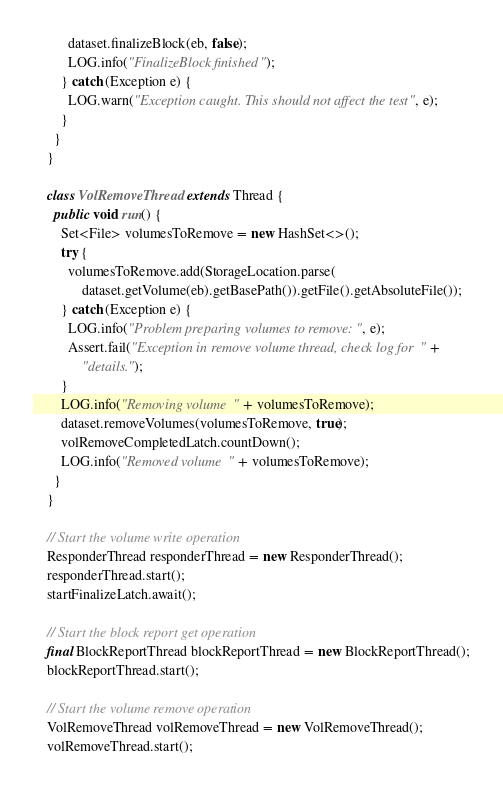<code> <loc_0><loc_0><loc_500><loc_500><_Java_>          dataset.finalizeBlock(eb, false);
          LOG.info("FinalizeBlock finished");
        } catch (Exception e) {
          LOG.warn("Exception caught. This should not affect the test", e);
        }
      }
    }

    class VolRemoveThread extends Thread {
      public void run() {
        Set<File> volumesToRemove = new HashSet<>();
        try {
          volumesToRemove.add(StorageLocation.parse(
              dataset.getVolume(eb).getBasePath()).getFile().getAbsoluteFile());
        } catch (Exception e) {
          LOG.info("Problem preparing volumes to remove: ", e);
          Assert.fail("Exception in remove volume thread, check log for " +
              "details.");
        }
        LOG.info("Removing volume " + volumesToRemove);
        dataset.removeVolumes(volumesToRemove, true);
        volRemoveCompletedLatch.countDown();
        LOG.info("Removed volume " + volumesToRemove);
      }
    }

    // Start the volume write operation
    ResponderThread responderThread = new ResponderThread();
    responderThread.start();
    startFinalizeLatch.await();

    // Start the block report get operation
    final BlockReportThread blockReportThread = new BlockReportThread();
    blockReportThread.start();

    // Start the volume remove operation
    VolRemoveThread volRemoveThread = new VolRemoveThread();
    volRemoveThread.start();
</code> 